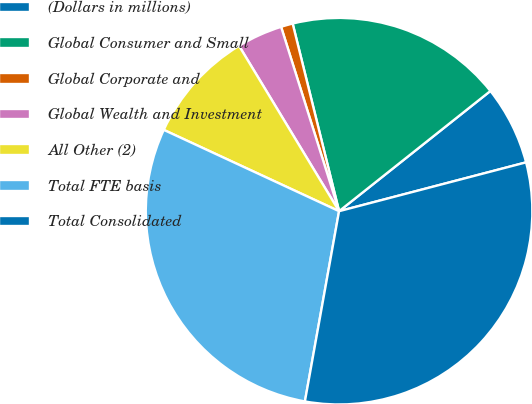Convert chart to OTSL. <chart><loc_0><loc_0><loc_500><loc_500><pie_chart><fcel>(Dollars in millions)<fcel>Global Consumer and Small<fcel>Global Corporate and<fcel>Global Wealth and Investment<fcel>All Other (2)<fcel>Total FTE basis<fcel>Total Consolidated<nl><fcel>6.62%<fcel>18.18%<fcel>0.99%<fcel>3.81%<fcel>9.43%<fcel>29.09%<fcel>31.9%<nl></chart> 